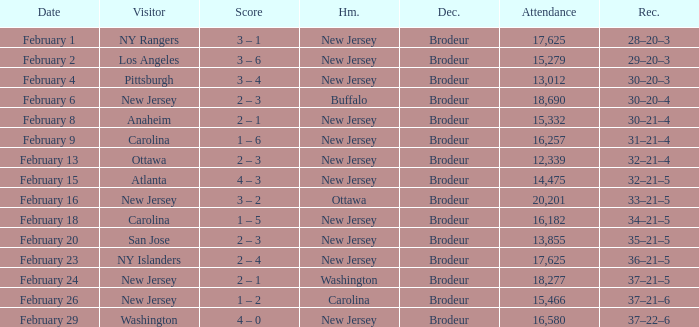What was the record when the visiting team was Ottawa? 32–21–4. 